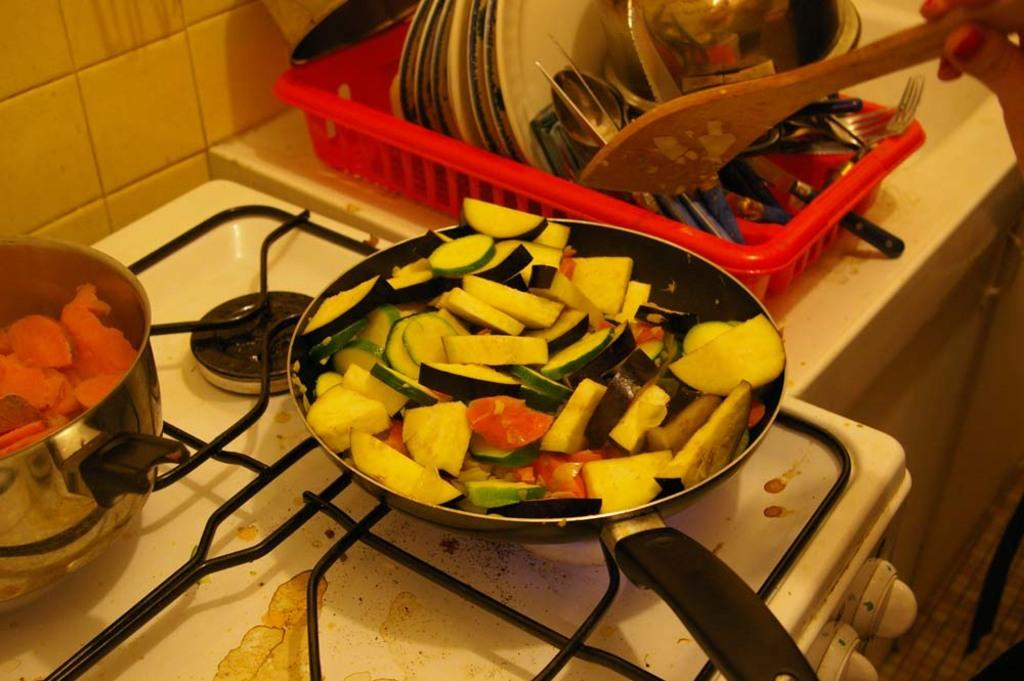What is being cooked in the pan in the image? The facts do not specify what type of food is in the pan. What is the purpose of the bowl in the image? The bowl's purpose cannot be determined from the facts provided. What is the stove used for in the image? The stove is used for cooking, as it is present in the image. What can be used for serving or eating food in the image? There are many utensils in the image that can be used for serving or eating food. Whose hand is visible in the image? A person's hand is visible in the image, but the facts do not specify whose hand it is. What type of punishment is being administered in the image? There is no indication of punishment in the image; it features a pan, a bowl, a stove, utensils, and a person's hand. What type of play is being depicted in the image? There is no play depicted in the image; it features a pan, a bowl, a stove, utensils, and a person's hand. 